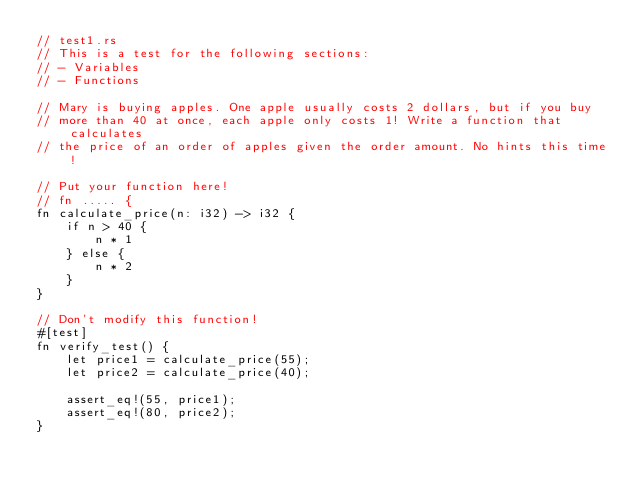<code> <loc_0><loc_0><loc_500><loc_500><_Rust_>// test1.rs
// This is a test for the following sections:
// - Variables
// - Functions

// Mary is buying apples. One apple usually costs 2 dollars, but if you buy
// more than 40 at once, each apple only costs 1! Write a function that calculates
// the price of an order of apples given the order amount. No hints this time!

// Put your function here!
// fn ..... {
fn calculate_price(n: i32) -> i32 {
    if n > 40 {
        n * 1
    } else {
        n * 2
    }
}

// Don't modify this function!
#[test]
fn verify_test() {
    let price1 = calculate_price(55);
    let price2 = calculate_price(40);

    assert_eq!(55, price1);
    assert_eq!(80, price2);
}
</code> 